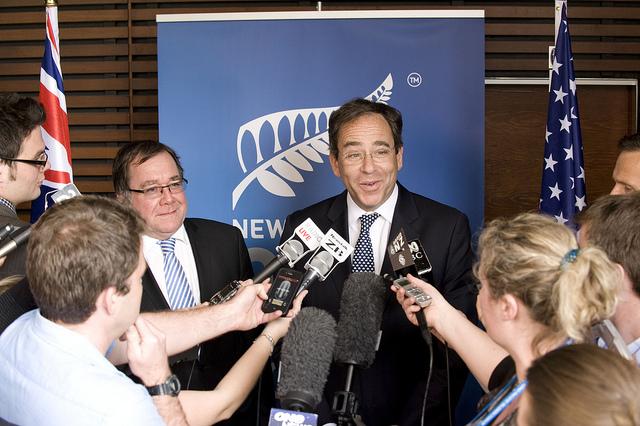Is this person being interviewed?
Short answer required. Yes. What flags are in the picture?
Concise answer only. American and british. Is this person happy?
Answer briefly. Yes. 